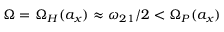<formula> <loc_0><loc_0><loc_500><loc_500>\Omega = \Omega _ { H } ( a _ { x } ) \approx \omega _ { 2 1 } / 2 < \Omega _ { P } ( a _ { x } )</formula> 